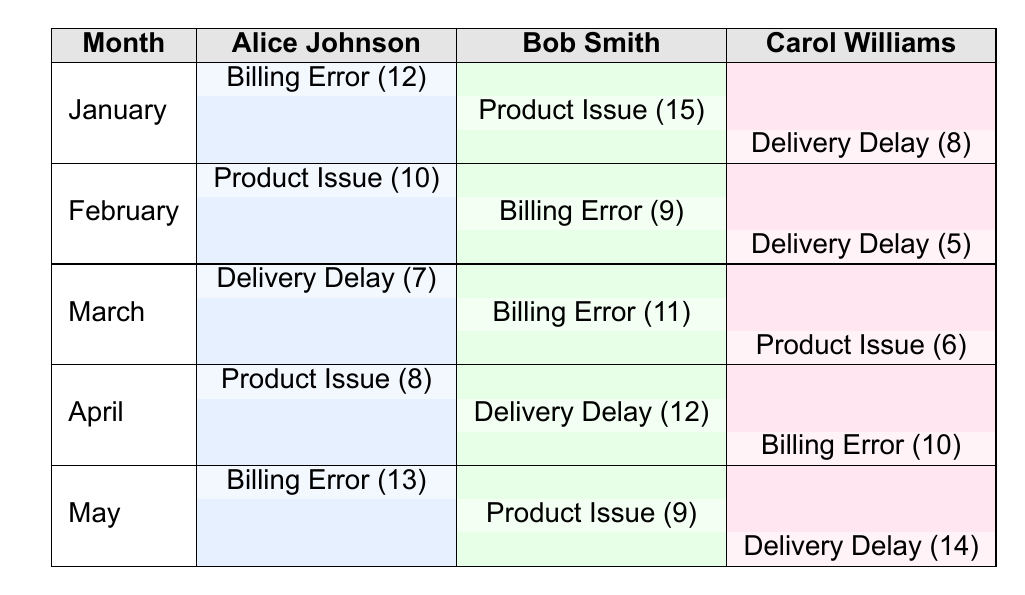What is the frequency of complaints handled by Alice Johnson in January? In January, Alice Johnson handled a complaint type "Billing Error" with a frequency of 12.
Answer: 12 Which month had the highest number of complaints for Bob Smith? Bob Smith's highest frequency is in January with "Product Issue" totaling 15.
Answer: January What is the total frequency of "Delivery Delay" complaints in February? In February, the frequency for "Delivery Delay" handled by Carol Williams is 5, making the total frequency for that month 5.
Answer: 5 How many complaints did Carol Williams handle in May? In May, Carol Williams had "Delivery Delay" with a frequency of 14. Therefore, the total frequency of complaints handled by her that month is 14.
Answer: 14 Did Alice Johnson receive more complaints in May than in April? In May, Alice Johnson handled "Billing Error" with a frequency of 13, while in April she handled "Product Issue" with a frequency of 8. Since 13 is greater than 8, the statement is true.
Answer: Yes What is the average frequency of complaints handled by Bob Smith over the five months? Bob Smith's frequencies are: January (15), February (9), March (11), April (12), and May (9). The total is 15 + 9 + 11 + 12 + 9 = 56. Dividing by 5 months gives an average of 56/5 = 11.2.
Answer: 11.2 In which month did Alice Johnson handle the least frequency of complaints, and what was that frequency? The data shows that in March Alice Johnson handled "Delivery Delay" with the least frequency of 7.
Answer: March, 7 Which service agent had the highest total frequency of complaints across the five months? By adding up the complaints for each service agent: Alice Johnson (12 + 10 + 7 + 8 + 13 = 50), Bob Smith (15 + 9 + 11 + 12 + 9 = 56), and Carol Williams (8 + 5 + 6 + 10 + 14 = 43). Bob Smith has the highest total frequency of 56.
Answer: Bob Smith Was there a month in which all service agents had zero complaints? All months listed in the data show that each service agent had at least one complaint logged for every month. Therefore, there were no months with zero complaints recorded.
Answer: No 